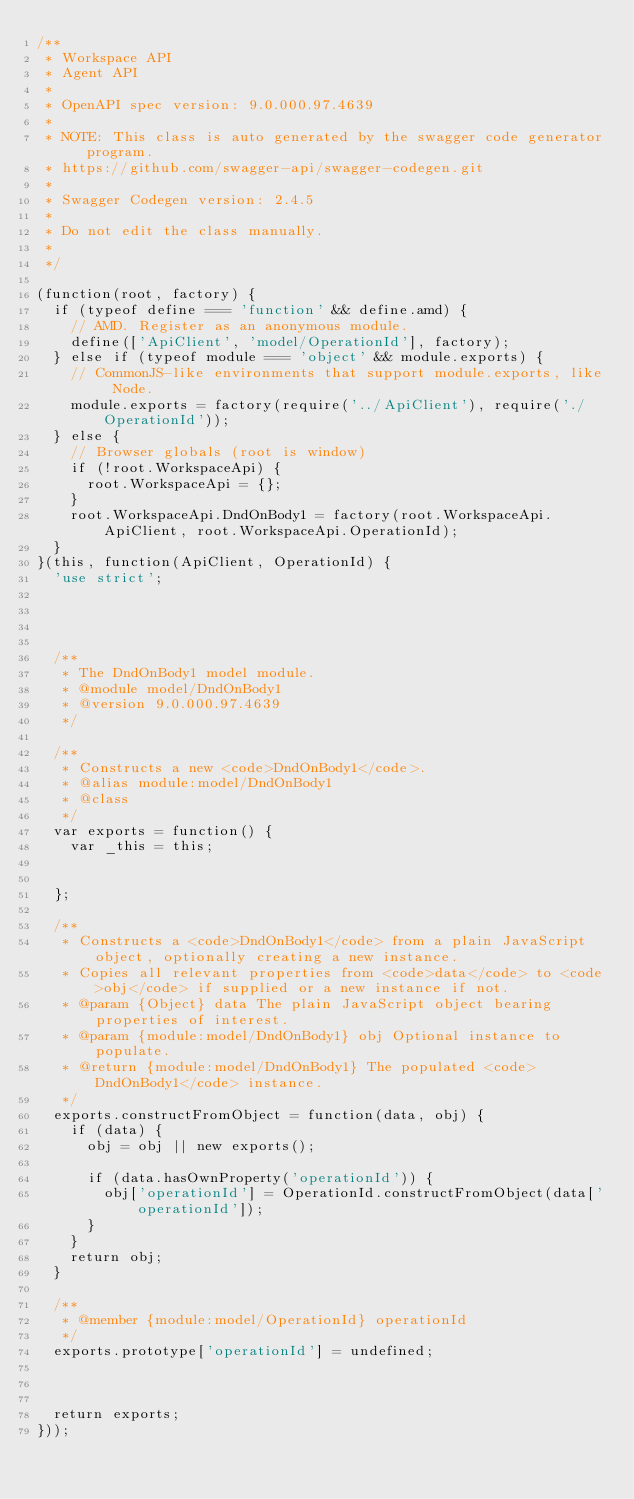<code> <loc_0><loc_0><loc_500><loc_500><_JavaScript_>/**
 * Workspace API
 * Agent API
 *
 * OpenAPI spec version: 9.0.000.97.4639
 *
 * NOTE: This class is auto generated by the swagger code generator program.
 * https://github.com/swagger-api/swagger-codegen.git
 *
 * Swagger Codegen version: 2.4.5
 *
 * Do not edit the class manually.
 *
 */

(function(root, factory) {
  if (typeof define === 'function' && define.amd) {
    // AMD. Register as an anonymous module.
    define(['ApiClient', 'model/OperationId'], factory);
  } else if (typeof module === 'object' && module.exports) {
    // CommonJS-like environments that support module.exports, like Node.
    module.exports = factory(require('../ApiClient'), require('./OperationId'));
  } else {
    // Browser globals (root is window)
    if (!root.WorkspaceApi) {
      root.WorkspaceApi = {};
    }
    root.WorkspaceApi.DndOnBody1 = factory(root.WorkspaceApi.ApiClient, root.WorkspaceApi.OperationId);
  }
}(this, function(ApiClient, OperationId) {
  'use strict';




  /**
   * The DndOnBody1 model module.
   * @module model/DndOnBody1
   * @version 9.0.000.97.4639
   */

  /**
   * Constructs a new <code>DndOnBody1</code>.
   * @alias module:model/DndOnBody1
   * @class
   */
  var exports = function() {
    var _this = this;


  };

  /**
   * Constructs a <code>DndOnBody1</code> from a plain JavaScript object, optionally creating a new instance.
   * Copies all relevant properties from <code>data</code> to <code>obj</code> if supplied or a new instance if not.
   * @param {Object} data The plain JavaScript object bearing properties of interest.
   * @param {module:model/DndOnBody1} obj Optional instance to populate.
   * @return {module:model/DndOnBody1} The populated <code>DndOnBody1</code> instance.
   */
  exports.constructFromObject = function(data, obj) {
    if (data) {
      obj = obj || new exports();

      if (data.hasOwnProperty('operationId')) {
        obj['operationId'] = OperationId.constructFromObject(data['operationId']);
      }
    }
    return obj;
  }

  /**
   * @member {module:model/OperationId} operationId
   */
  exports.prototype['operationId'] = undefined;



  return exports;
}));


</code> 